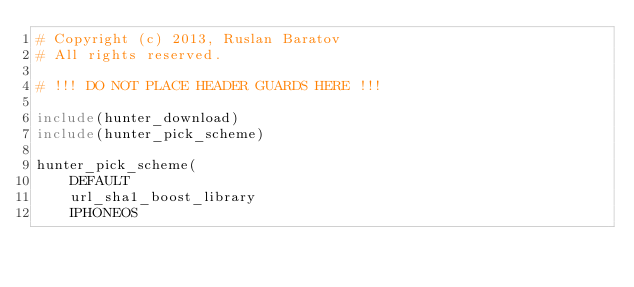<code> <loc_0><loc_0><loc_500><loc_500><_CMake_># Copyright (c) 2013, Ruslan Baratov
# All rights reserved.

# !!! DO NOT PLACE HEADER GUARDS HERE !!!

include(hunter_download)
include(hunter_pick_scheme)

hunter_pick_scheme(
    DEFAULT
    url_sha1_boost_library
    IPHONEOS</code> 